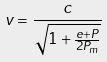Convert formula to latex. <formula><loc_0><loc_0><loc_500><loc_500>v = \frac { c } { \sqrt { 1 + \frac { e + P } { 2 P _ { m } } } }</formula> 